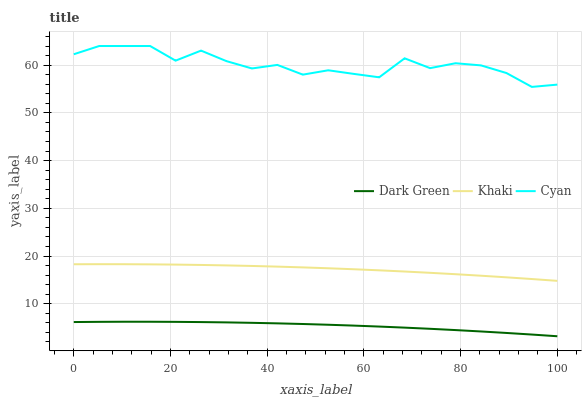Does Dark Green have the minimum area under the curve?
Answer yes or no. Yes. Does Cyan have the maximum area under the curve?
Answer yes or no. Yes. Does Khaki have the minimum area under the curve?
Answer yes or no. No. Does Khaki have the maximum area under the curve?
Answer yes or no. No. Is Khaki the smoothest?
Answer yes or no. Yes. Is Cyan the roughest?
Answer yes or no. Yes. Is Dark Green the smoothest?
Answer yes or no. No. Is Dark Green the roughest?
Answer yes or no. No. Does Dark Green have the lowest value?
Answer yes or no. Yes. Does Khaki have the lowest value?
Answer yes or no. No. Does Cyan have the highest value?
Answer yes or no. Yes. Does Khaki have the highest value?
Answer yes or no. No. Is Khaki less than Cyan?
Answer yes or no. Yes. Is Khaki greater than Dark Green?
Answer yes or no. Yes. Does Khaki intersect Cyan?
Answer yes or no. No. 